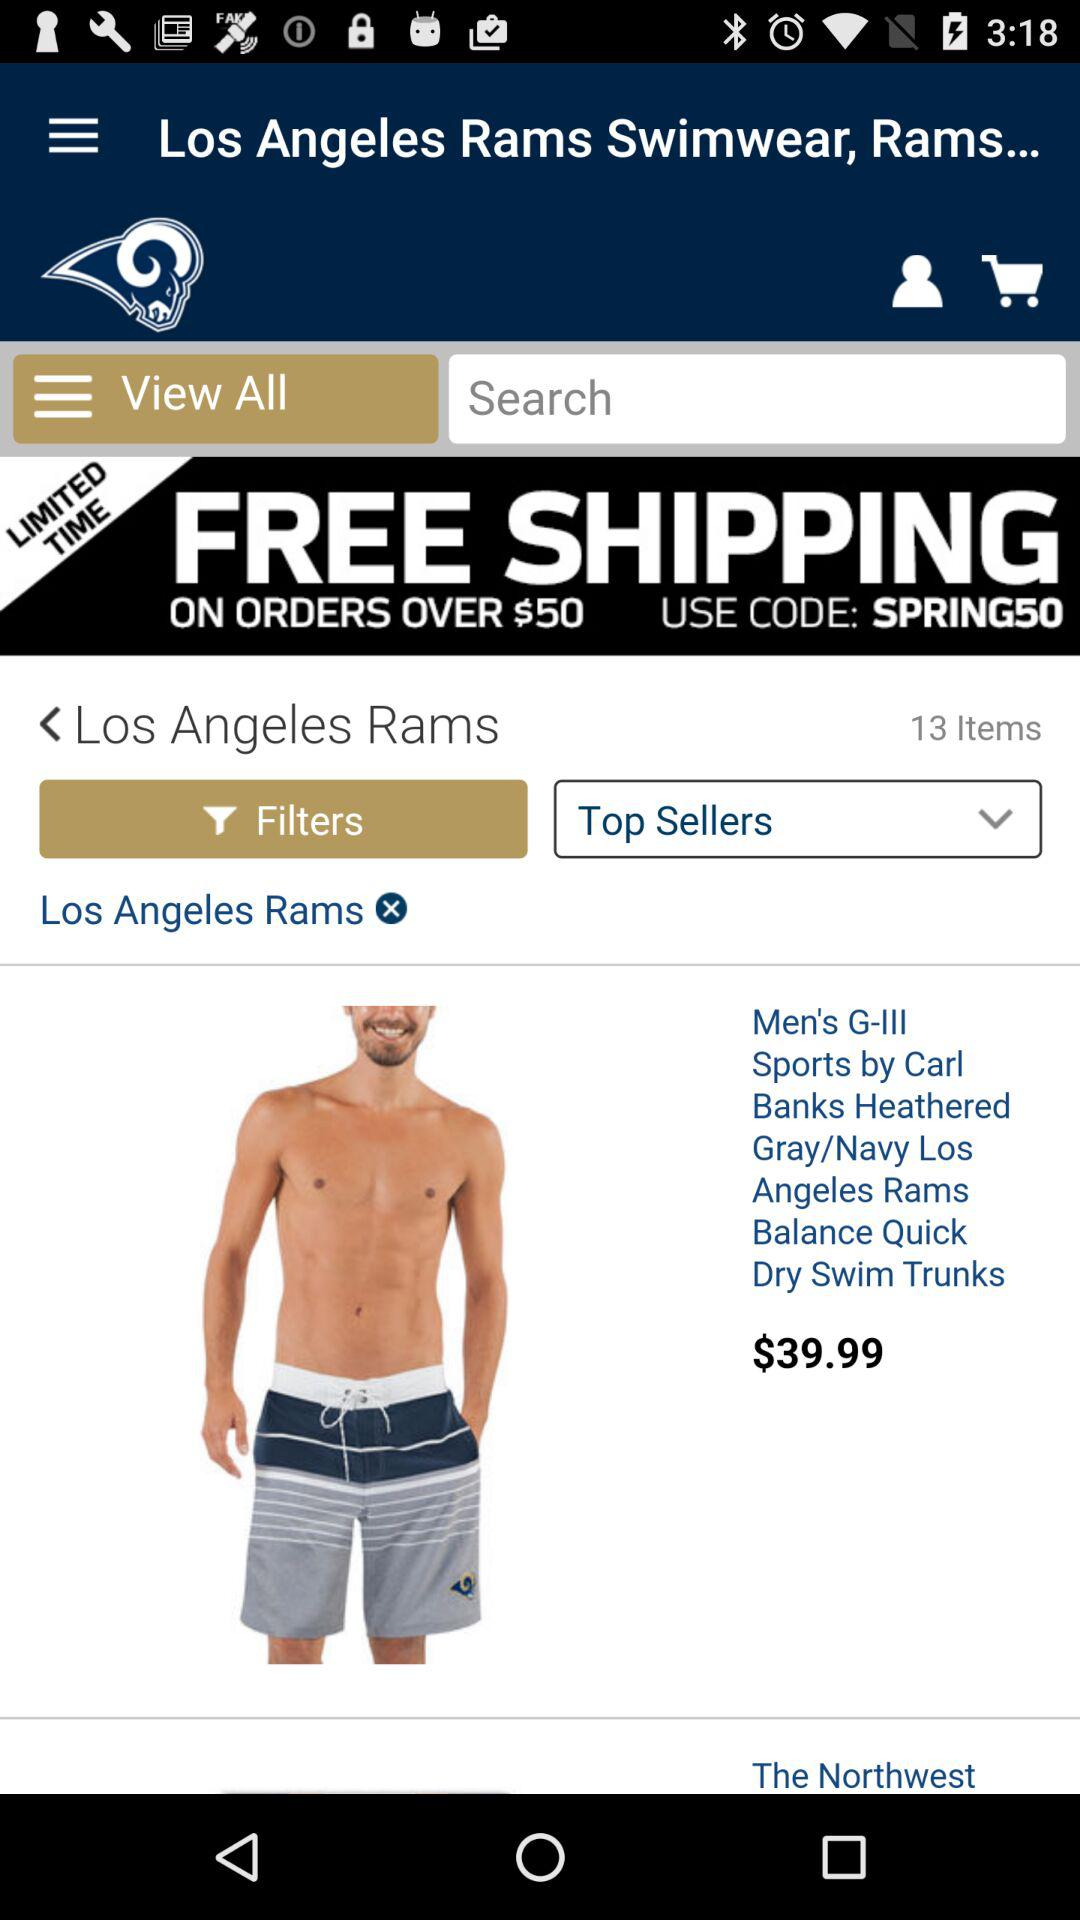How many items are there?
Answer the question using a single word or phrase. 13 